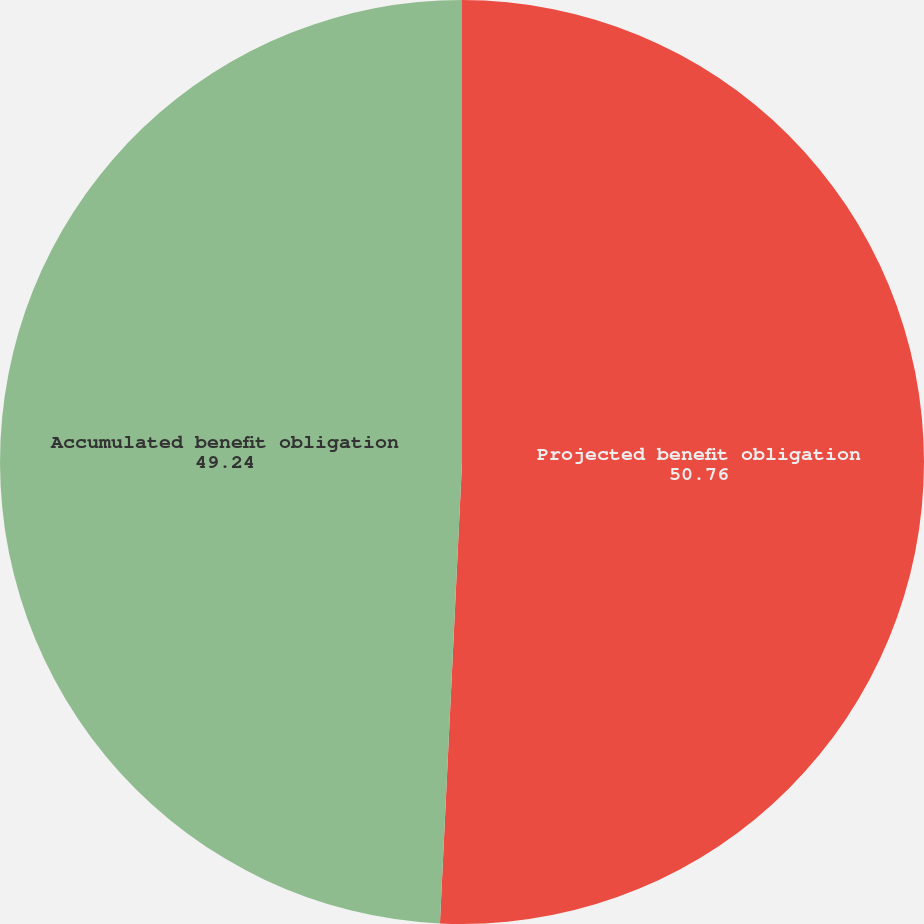Convert chart to OTSL. <chart><loc_0><loc_0><loc_500><loc_500><pie_chart><fcel>Projected benefit obligation<fcel>Accumulated benefit obligation<nl><fcel>50.76%<fcel>49.24%<nl></chart> 